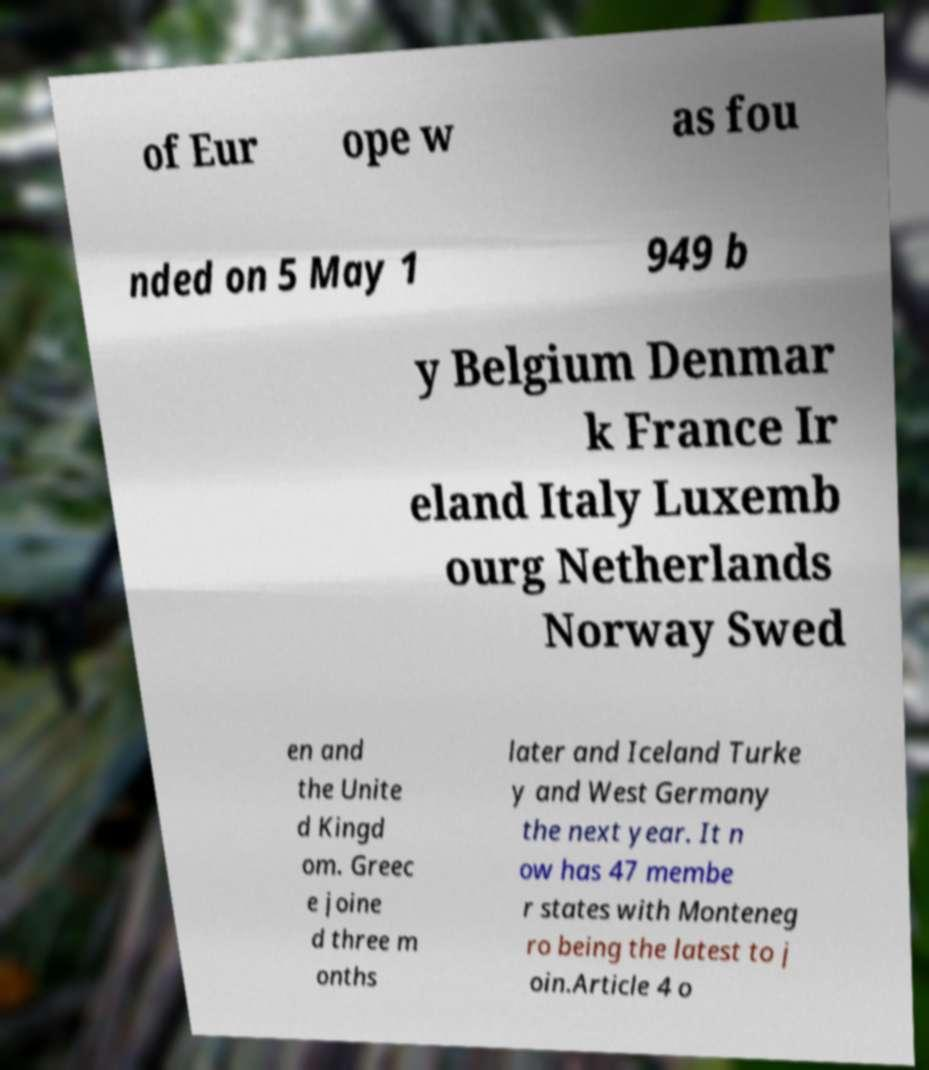What messages or text are displayed in this image? I need them in a readable, typed format. of Eur ope w as fou nded on 5 May 1 949 b y Belgium Denmar k France Ir eland Italy Luxemb ourg Netherlands Norway Swed en and the Unite d Kingd om. Greec e joine d three m onths later and Iceland Turke y and West Germany the next year. It n ow has 47 membe r states with Monteneg ro being the latest to j oin.Article 4 o 